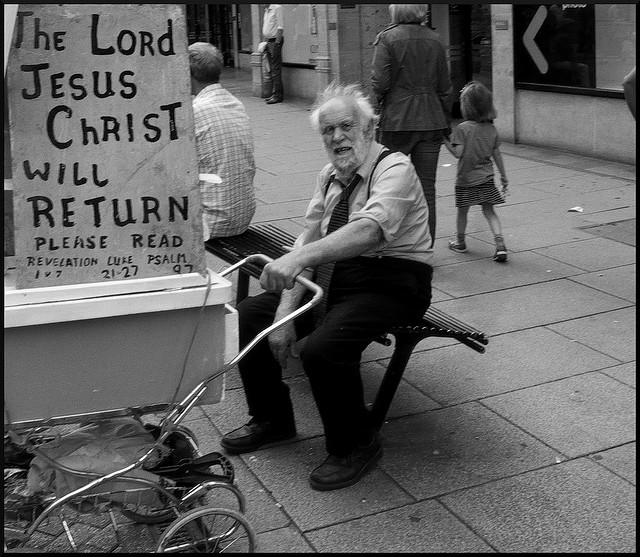What book is the man's sign referencing?

Choices:
A) dictionary
B) thesaurus
C) bible
D) encyclopedia bible 